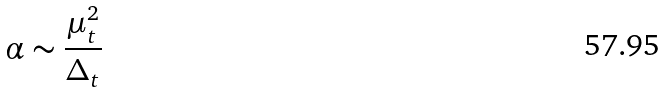<formula> <loc_0><loc_0><loc_500><loc_500>\alpha \sim \frac { \mu _ { t } ^ { 2 } } { \Delta _ { t } }</formula> 